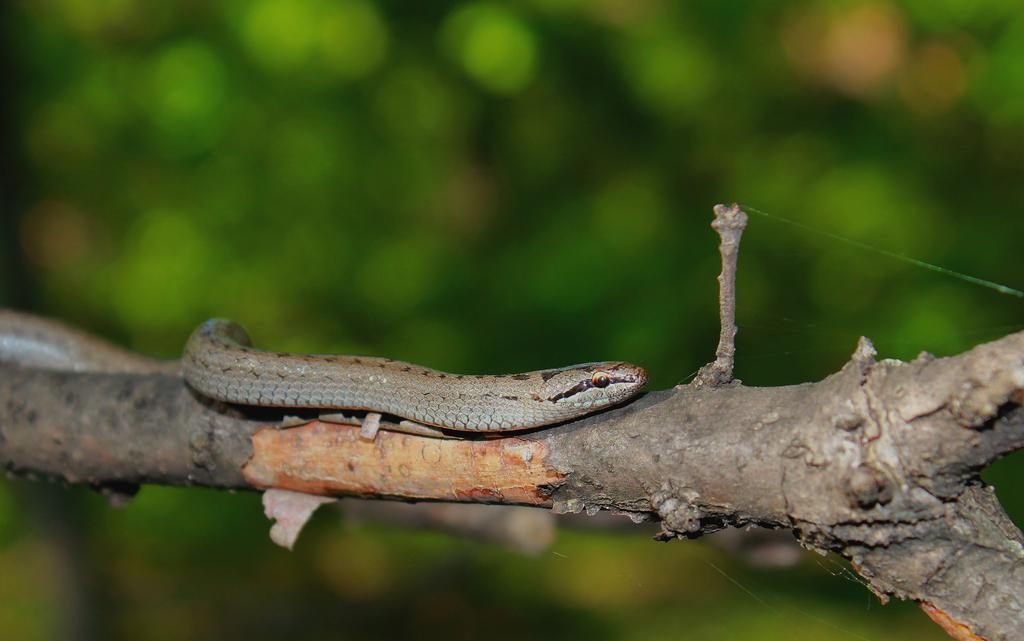Can you describe this image briefly? In this image I can see a snake on the branch and the background is in green color. 